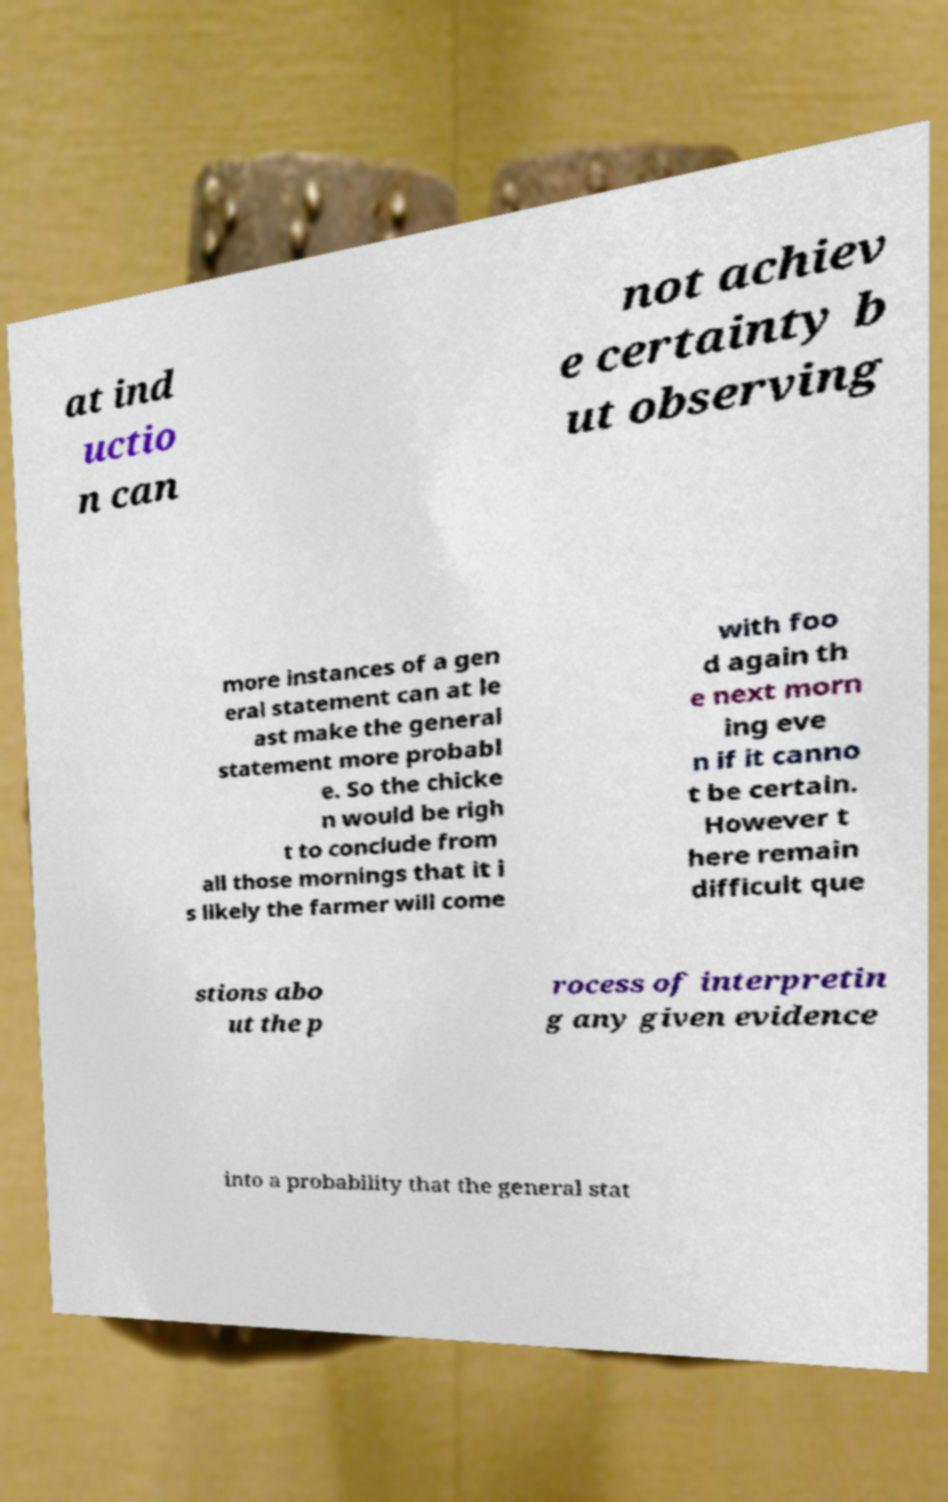I need the written content from this picture converted into text. Can you do that? at ind uctio n can not achiev e certainty b ut observing more instances of a gen eral statement can at le ast make the general statement more probabl e. So the chicke n would be righ t to conclude from all those mornings that it i s likely the farmer will come with foo d again th e next morn ing eve n if it canno t be certain. However t here remain difficult que stions abo ut the p rocess of interpretin g any given evidence into a probability that the general stat 